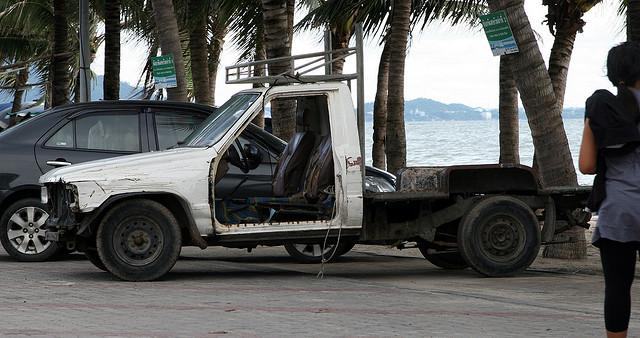What is the truck missing that would make it illegal in many countries? Please explain your reasoning. doors. The truck doesn't have doors near the chairs. 